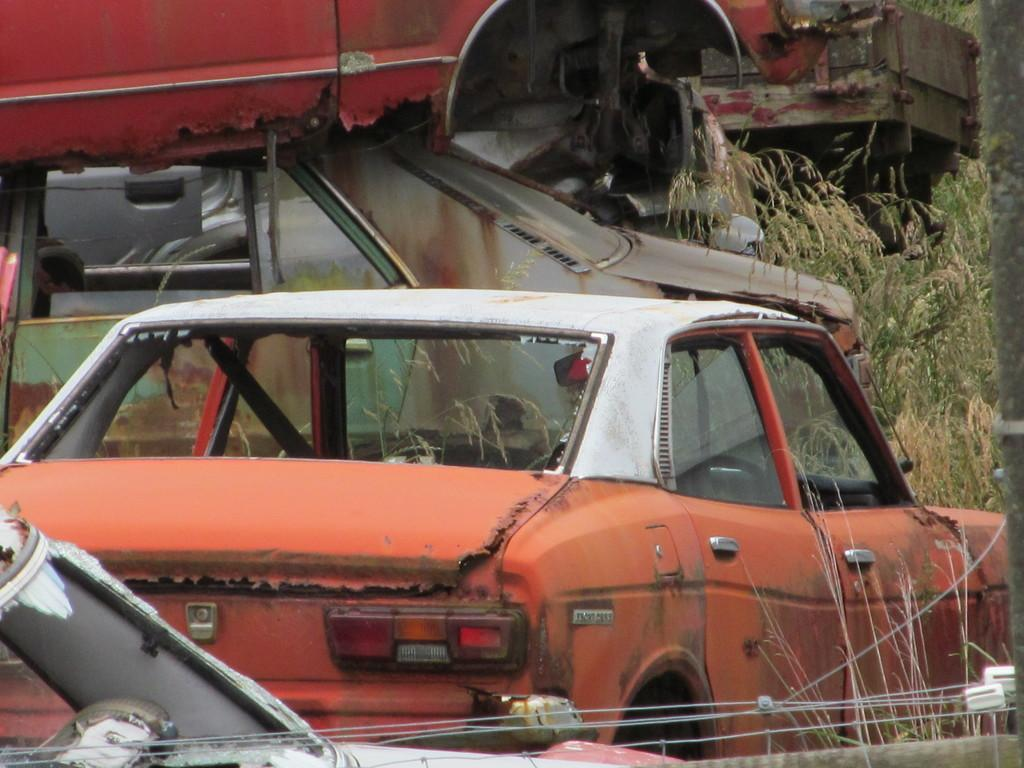What types of objects can be seen in the image? There are vehicles in the image. What type of natural environment is visible in the image? There is grass visible in the image. Are there any man-made structures or elements in the image? Yes, there are wires in the image. What type of wood can be seen in the image? There is no wood present in the image. Can you describe the chair in the image? There is no chair present in the image. 